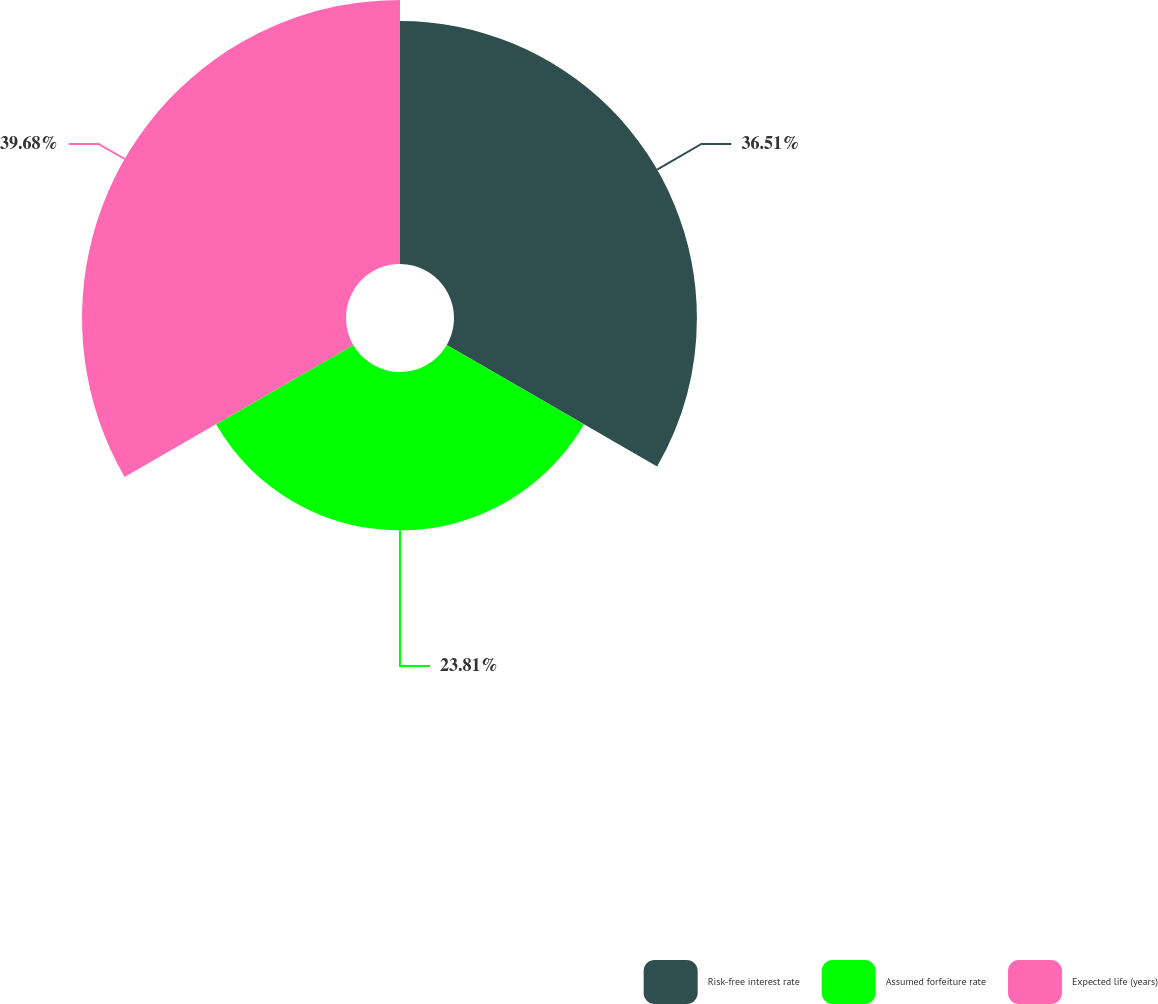<chart> <loc_0><loc_0><loc_500><loc_500><pie_chart><fcel>Risk-free interest rate<fcel>Assumed forfeiture rate<fcel>Expected life (years)<nl><fcel>36.51%<fcel>23.81%<fcel>39.68%<nl></chart> 